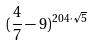Convert formula to latex. <formula><loc_0><loc_0><loc_500><loc_500>( \frac { 4 } { 7 } - 9 ) ^ { 2 0 4 \cdot \sqrt { 5 } }</formula> 